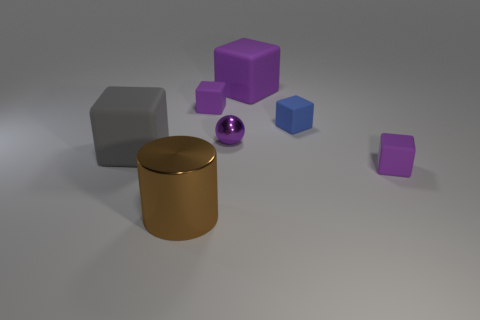How many spheres are either large gray things or purple rubber things?
Make the answer very short. 0. Is there any other thing that has the same size as the cylinder?
Ensure brevity in your answer.  Yes. What number of metal objects are behind the block to the left of the big brown thing in front of the blue rubber block?
Your response must be concise. 1. Is the shape of the big gray rubber thing the same as the large purple object?
Make the answer very short. Yes. Are the big block right of the brown shiny cylinder and the tiny thing that is on the left side of the purple metal thing made of the same material?
Offer a terse response. Yes. How many things are either tiny things that are behind the gray matte block or things that are left of the brown metallic object?
Offer a very short reply. 4. Is there anything else that has the same shape as the large gray matte object?
Ensure brevity in your answer.  Yes. What number of big brown shiny objects are there?
Ensure brevity in your answer.  1. Is there a rubber cube that has the same size as the gray matte object?
Provide a succinct answer. Yes. Does the big gray thing have the same material as the big object that is to the right of the brown metal thing?
Provide a short and direct response. Yes. 